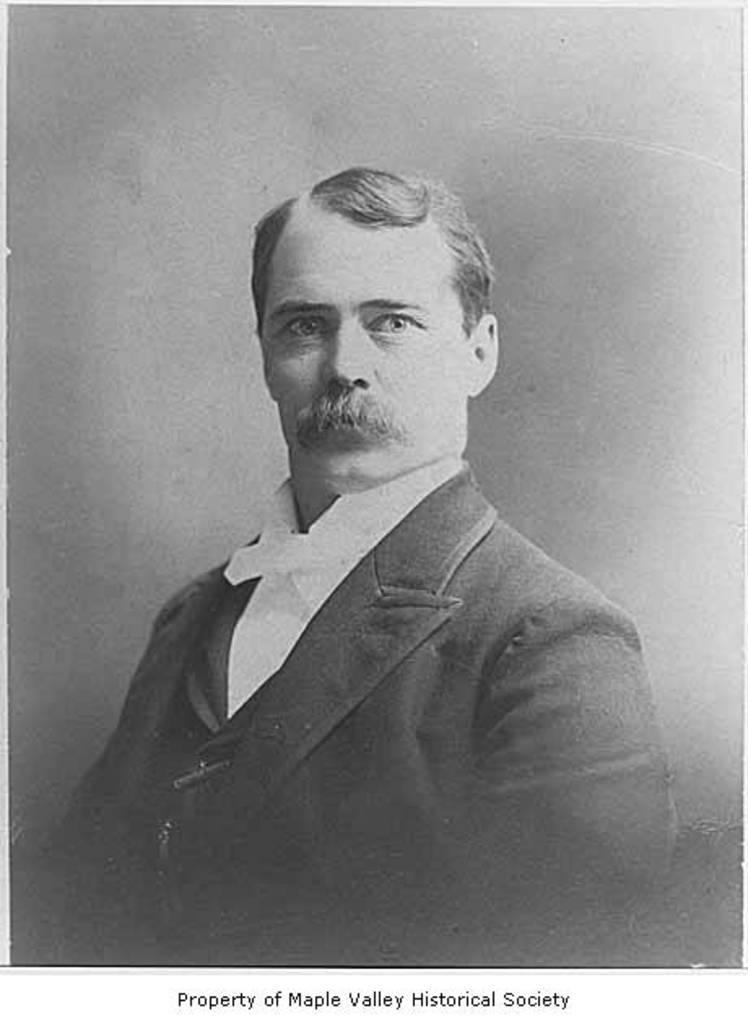How would you summarize this image in a sentence or two? This is a black and white picture. In this picture, we see a man is wearing the white shirt and black blazer. He might be posing for the photo. In the background, it is grey in color. At the bottom, we see some text written. This might be a photo frame. 